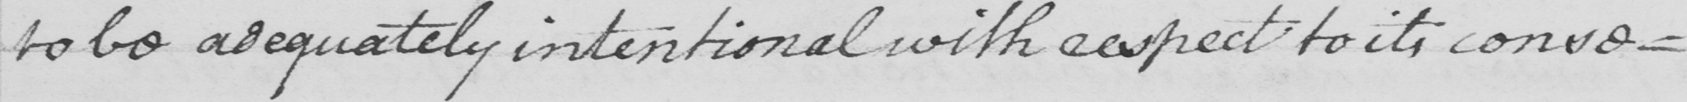Please transcribe the handwritten text in this image. to be adequately intentional with respect to its conse- 